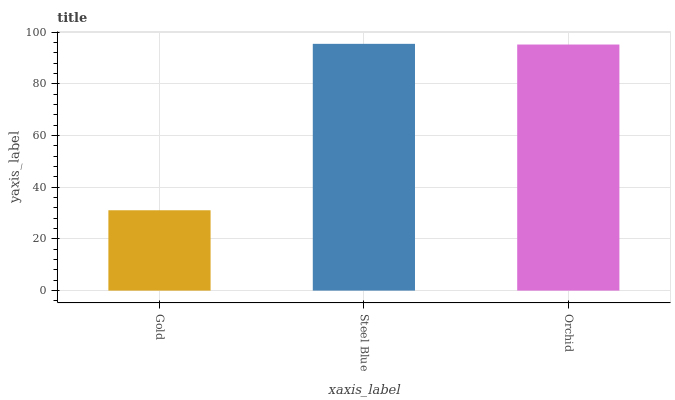Is Gold the minimum?
Answer yes or no. Yes. Is Steel Blue the maximum?
Answer yes or no. Yes. Is Orchid the minimum?
Answer yes or no. No. Is Orchid the maximum?
Answer yes or no. No. Is Steel Blue greater than Orchid?
Answer yes or no. Yes. Is Orchid less than Steel Blue?
Answer yes or no. Yes. Is Orchid greater than Steel Blue?
Answer yes or no. No. Is Steel Blue less than Orchid?
Answer yes or no. No. Is Orchid the high median?
Answer yes or no. Yes. Is Orchid the low median?
Answer yes or no. Yes. Is Gold the high median?
Answer yes or no. No. Is Gold the low median?
Answer yes or no. No. 